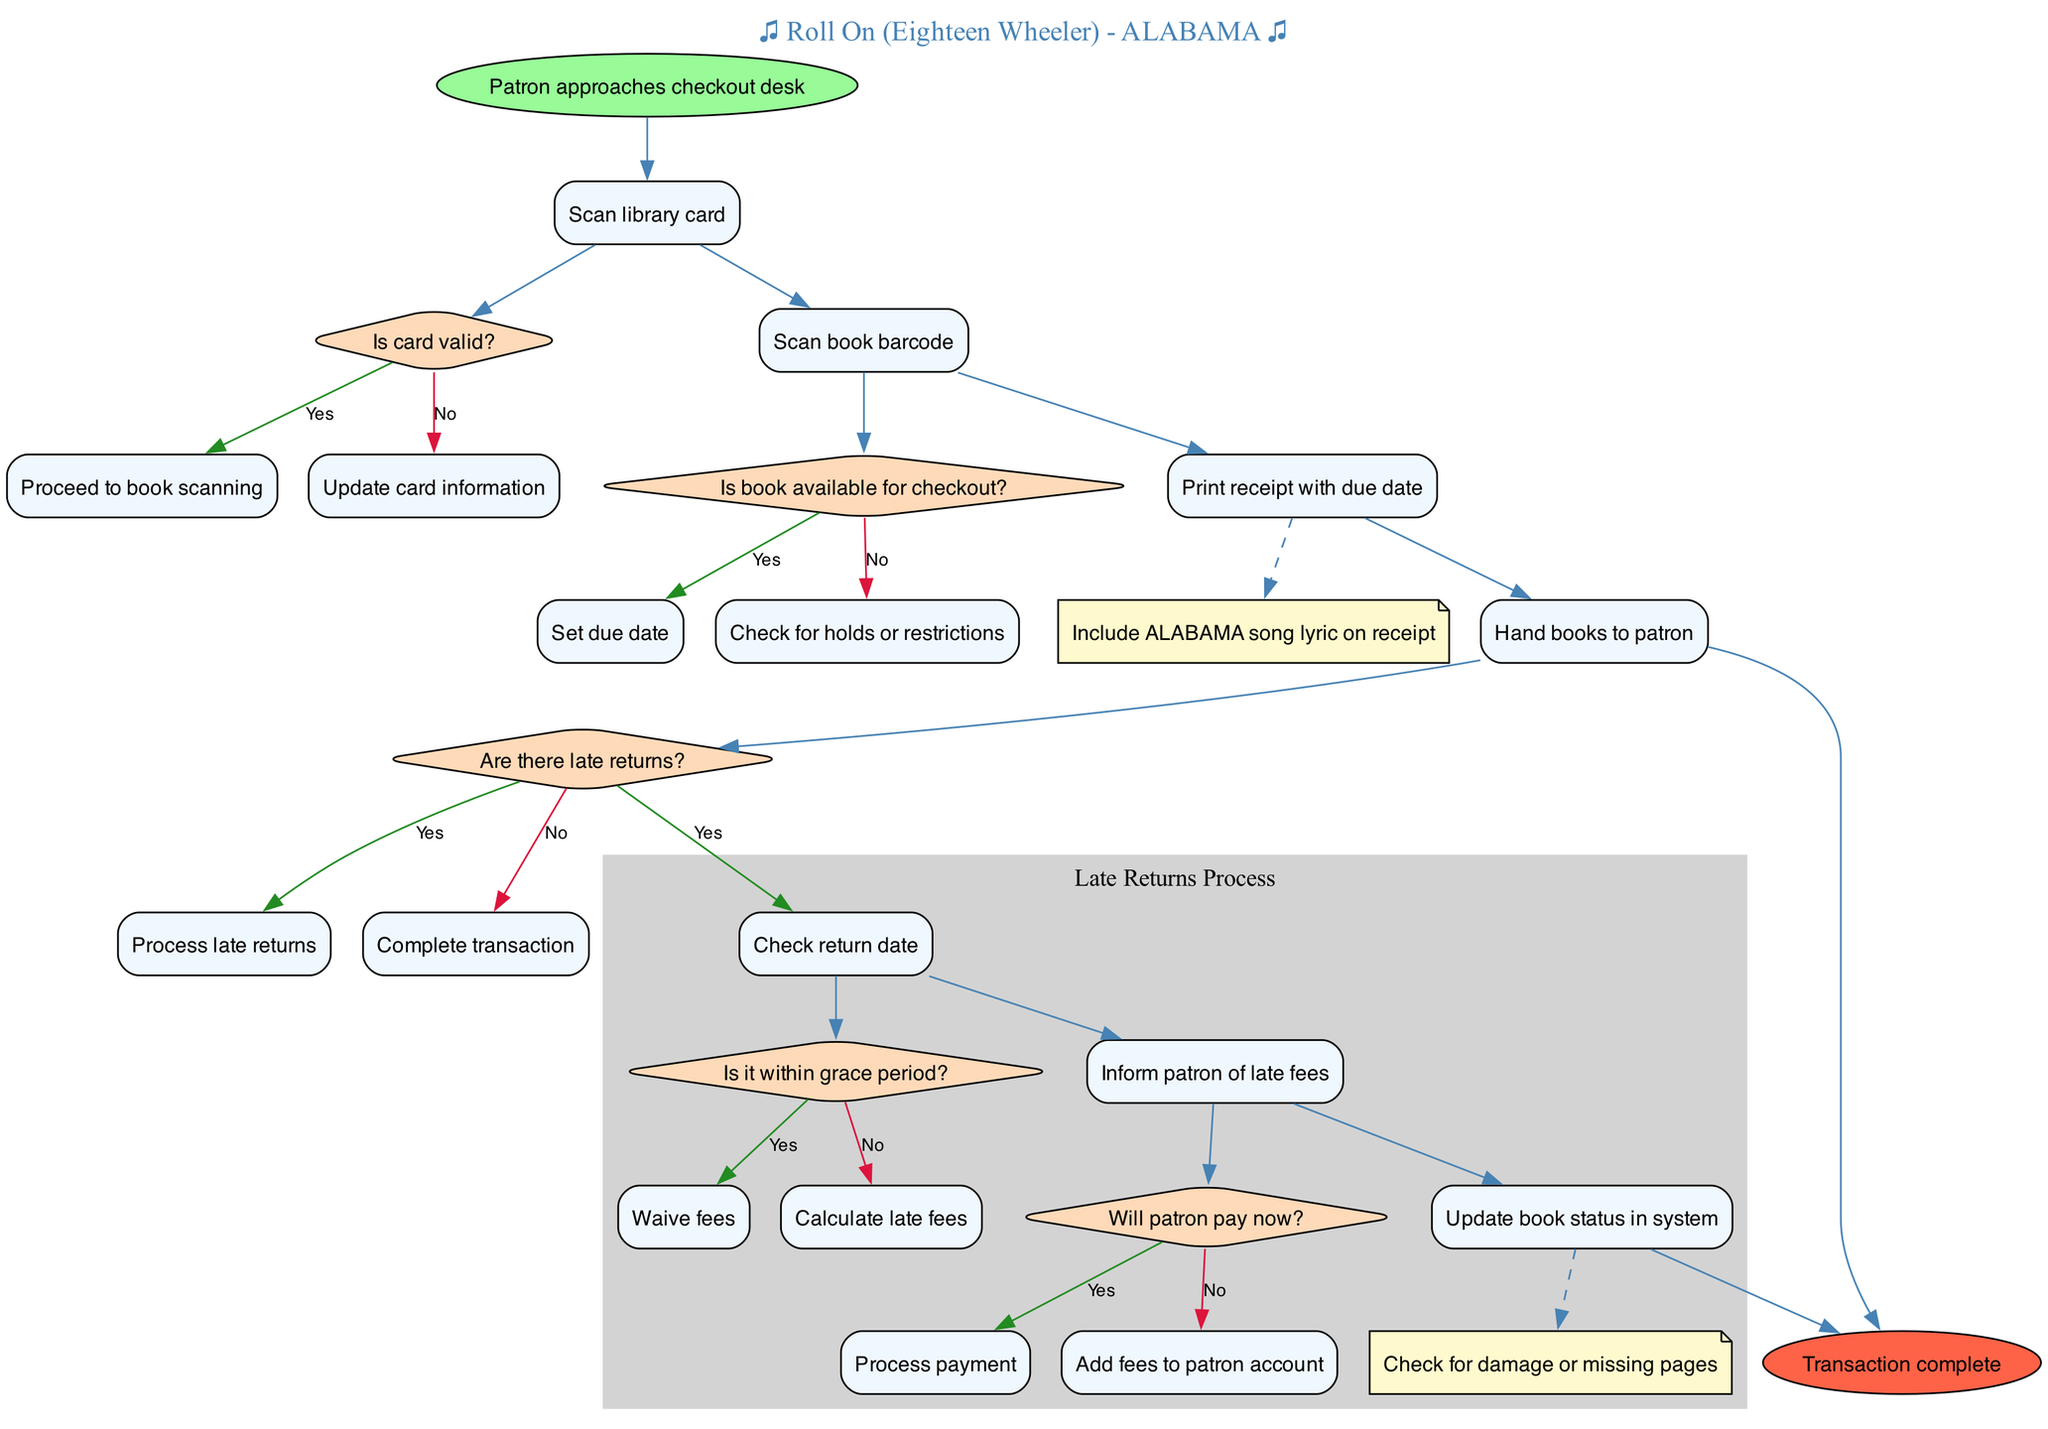What action does the patron take first at the checkout desk? The first action in the diagram is "Patron approaches checkout desk." This indicates the starting point of the checkout process.
Answer: Patron approaches checkout desk What decision is made after scanning the library card? After scanning the library card, the decision is "Is card valid?" This is the next step in the process that determines how to proceed.
Answer: Is card valid? How many steps are involved in the main checkout process before reaching late returns? The main checkout process consists of four steps leading to handling late returns. These are actions taken prior to checking for any late returns.
Answer: Four steps What happens if the book is not available for checkout? If the book is not available for checkout, the process directs to "Check for holds or restrictions." This indicates what the librarian needs to do next if the book cannot be checked out.
Answer: Check for holds or restrictions In the case of late returns, what is the first action taken? The first action taken in the late returns process is "Check return date." This starts the handling of any late returns reported by the patron.
Answer: Check return date If the return date is within the grace period, what happens next? If the return date is within the grace period, the process indicates to "Waive fees." This means the patron will not incur any fees for the late return.
Answer: Waive fees How does the process handle payment for late fees if the patron chooses not to pay immediately? If the patron chooses not to pay immediately, the process leads to "Add fees to patron account." This indicates that the fees will be logged for future payment.
Answer: Add fees to patron account What is included in the receipt printed during the checkout process? The receipt printed during the checkout process includes "Include ALABAMA song lyric on receipt." This adds a personal touch reflecting the band fandom.
Answer: Include ALABAMA song lyric on receipt What is the final outcome of the transaction process? The final outcome of the transaction process is defined as "Transaction complete." This indicates the conclusion of the entire checkout and return handling.
Answer: Transaction complete 